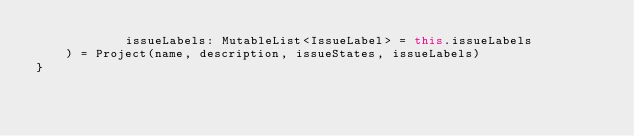<code> <loc_0><loc_0><loc_500><loc_500><_Kotlin_>            issueLabels: MutableList<IssueLabel> = this.issueLabels
    ) = Project(name, description, issueStates, issueLabels)
}</code> 